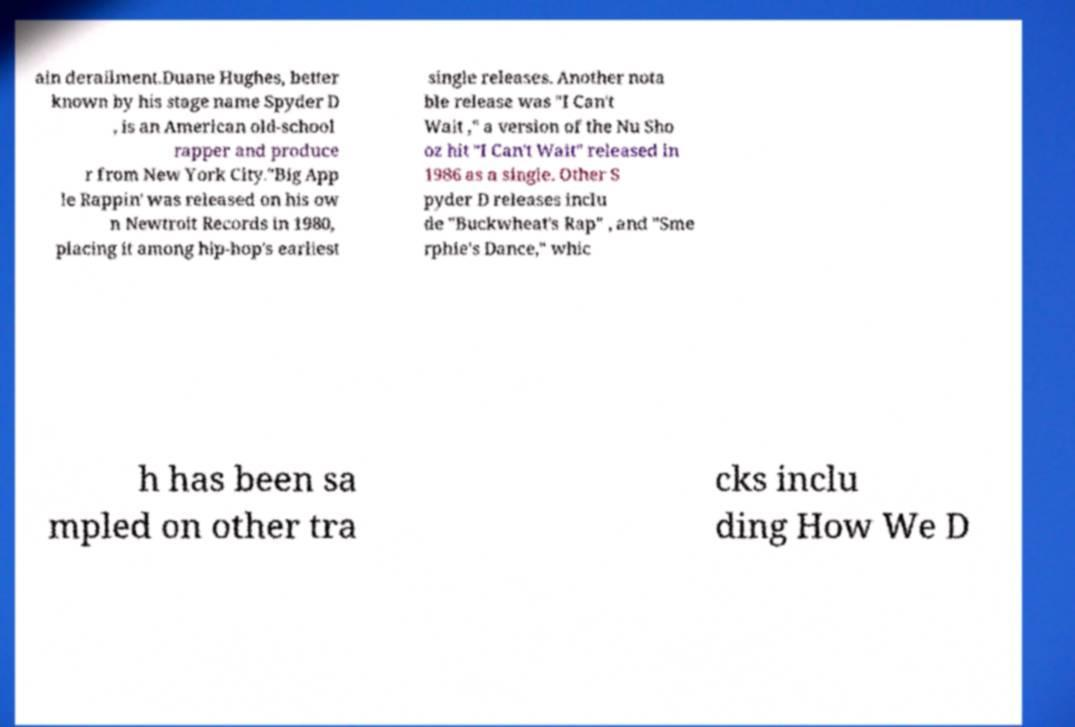Could you extract and type out the text from this image? ain derailment.Duane Hughes, better known by his stage name Spyder D , is an American old-school rapper and produce r from New York City."Big App le Rappin' was released on his ow n Newtroit Records in 1980, placing it among hip-hop's earliest single releases. Another nota ble release was "I Can't Wait ," a version of the Nu Sho oz hit "I Can't Wait" released in 1986 as a single. Other S pyder D releases inclu de "Buckwheat's Rap" , and "Sme rphie's Dance," whic h has been sa mpled on other tra cks inclu ding How We D 